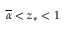Convert formula to latex. <formula><loc_0><loc_0><loc_500><loc_500>\overline { \alpha } < z _ { * } < 1</formula> 